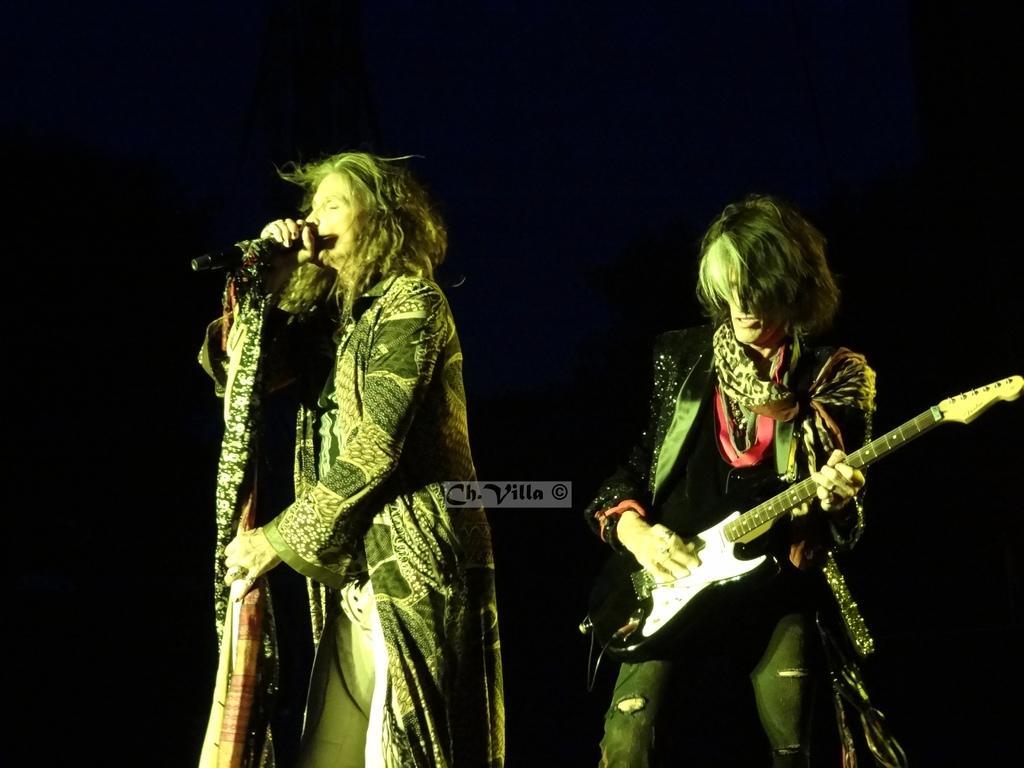Could you give a brief overview of what you see in this image? There is a man holding and playing guitar. Beside him, there is a woman holding a mic and singing. The background is in dark color. 